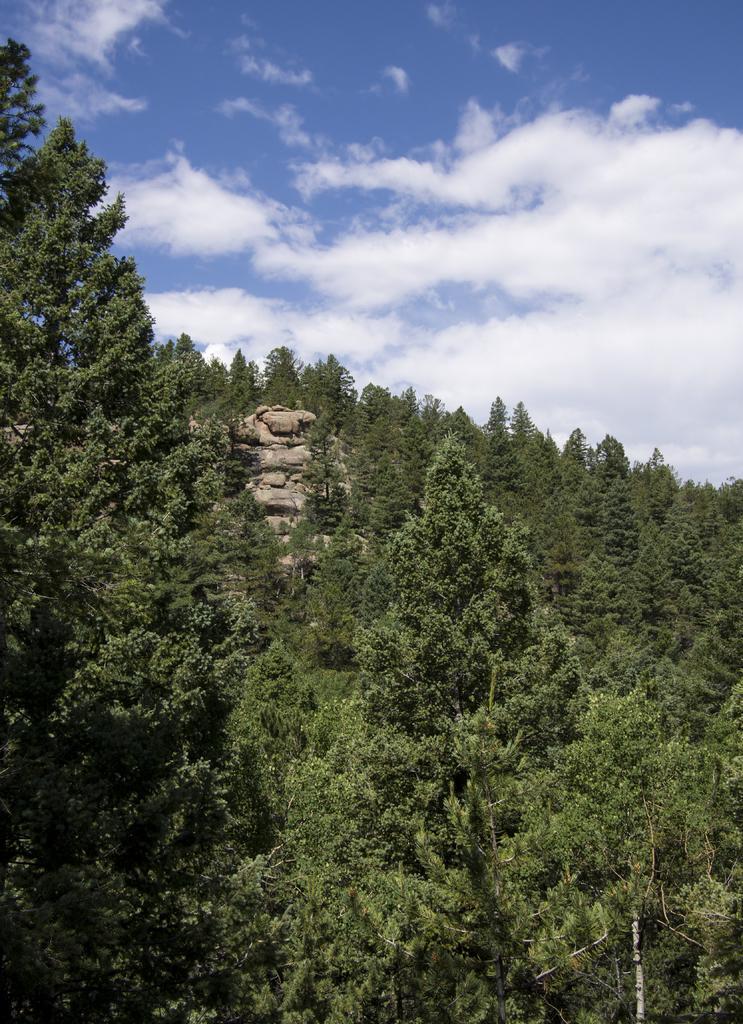Can you describe this image briefly? This is an aerial view. In this picture we can see the trees and rock. At the top of the image we can see the clouds are present in the sky. 